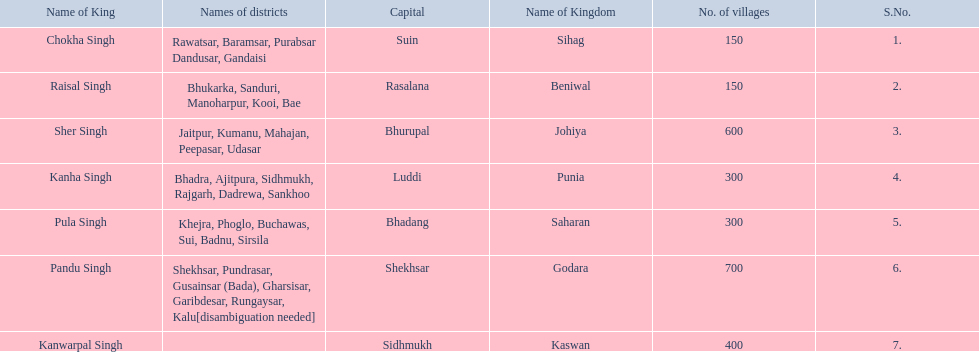Can you parse all the data within this table? {'header': ['Name of King', 'Names of districts', 'Capital', 'Name of Kingdom', 'No. of villages', 'S.No.'], 'rows': [['Chokha Singh', 'Rawatsar, Baramsar, Purabsar Dandusar, Gandaisi', 'Suin', 'Sihag', '150', '1.'], ['Raisal Singh', 'Bhukarka, Sanduri, Manoharpur, Kooi, Bae', 'Rasalana', 'Beniwal', '150', '2.'], ['Sher Singh', 'Jaitpur, Kumanu, Mahajan, Peepasar, Udasar', 'Bhurupal', 'Johiya', '600', '3.'], ['Kanha Singh', 'Bhadra, Ajitpura, Sidhmukh, Rajgarh, Dadrewa, Sankhoo', 'Luddi', 'Punia', '300', '4.'], ['Pula Singh', 'Khejra, Phoglo, Buchawas, Sui, Badnu, Sirsila', 'Bhadang', 'Saharan', '300', '5.'], ['Pandu Singh', 'Shekhsar, Pundrasar, Gusainsar (Bada), Gharsisar, Garibdesar, Rungaysar, Kalu[disambiguation needed]', 'Shekhsar', 'Godara', '700', '6.'], ['Kanwarpal Singh', '', 'Sidhmukh', 'Kaswan', '400', '7.']]} Which kingdom has the most villages? Godara. 